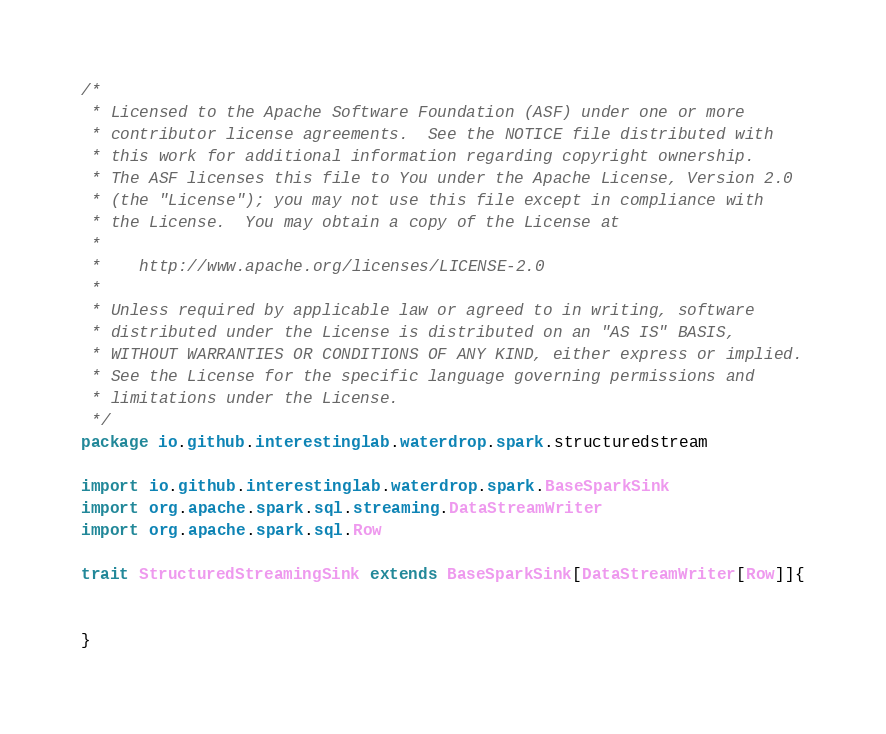Convert code to text. <code><loc_0><loc_0><loc_500><loc_500><_Scala_>/*
 * Licensed to the Apache Software Foundation (ASF) under one or more
 * contributor license agreements.  See the NOTICE file distributed with
 * this work for additional information regarding copyright ownership.
 * The ASF licenses this file to You under the Apache License, Version 2.0
 * (the "License"); you may not use this file except in compliance with
 * the License.  You may obtain a copy of the License at
 *
 *    http://www.apache.org/licenses/LICENSE-2.0
 *
 * Unless required by applicable law or agreed to in writing, software
 * distributed under the License is distributed on an "AS IS" BASIS,
 * WITHOUT WARRANTIES OR CONDITIONS OF ANY KIND, either express or implied.
 * See the License for the specific language governing permissions and
 * limitations under the License.
 */
package io.github.interestinglab.waterdrop.spark.structuredstream

import io.github.interestinglab.waterdrop.spark.BaseSparkSink
import org.apache.spark.sql.streaming.DataStreamWriter
import org.apache.spark.sql.Row

trait StructuredStreamingSink extends BaseSparkSink[DataStreamWriter[Row]]{

  
}
</code> 